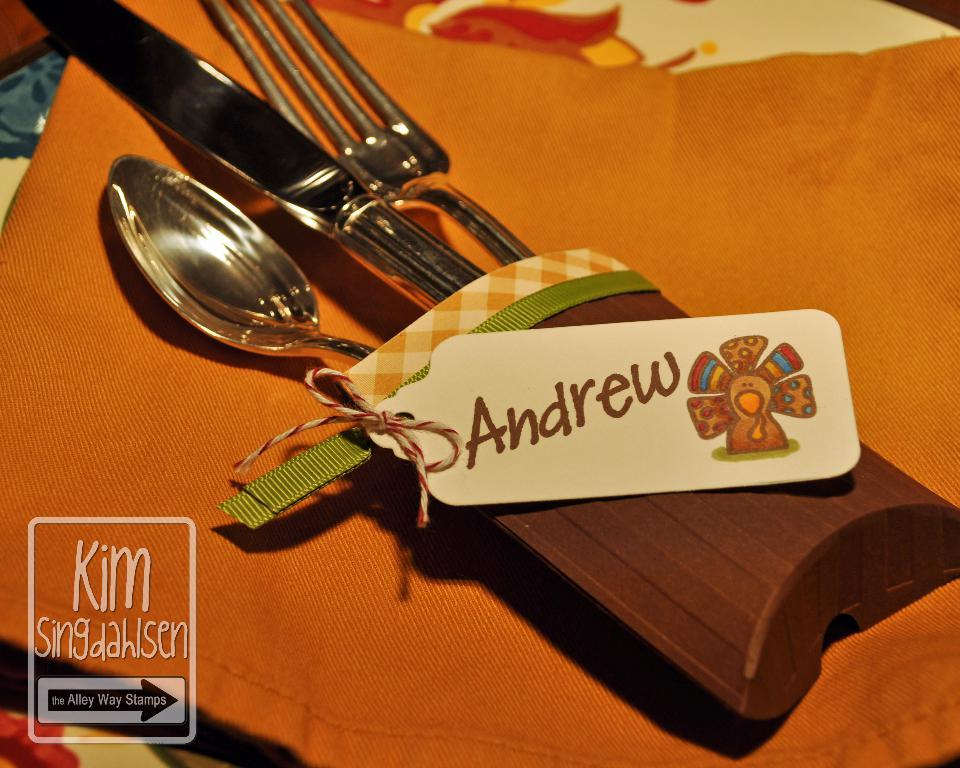What utensils can be seen in the image? There is a spoon, a fork, and a knife in the image. What color is the cloth in the image? The cloth is in orange color. How many trucks are visible in the image? There are no trucks present in the image. What shape is the circle in the image? There is no circle present in the image. 